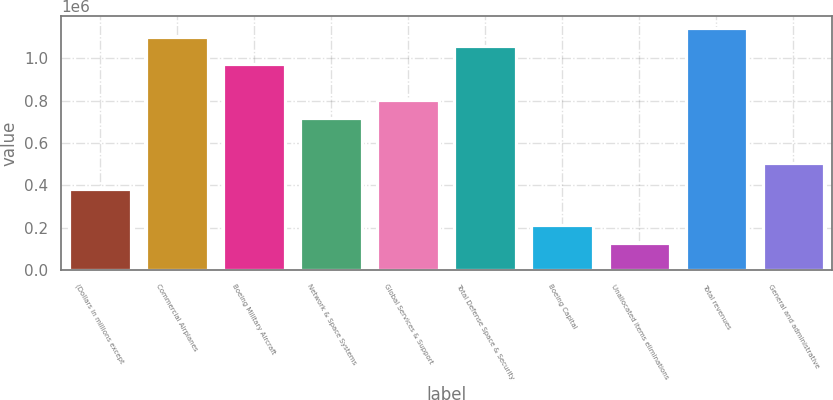Convert chart to OTSL. <chart><loc_0><loc_0><loc_500><loc_500><bar_chart><fcel>(Dollars in millions except<fcel>Commercial Airplanes<fcel>Boeing Military Aircraft<fcel>Network & Space Systems<fcel>Global Services & Support<fcel>Total Defense Space & Security<fcel>Boeing Capital<fcel>Unallocated items eliminations<fcel>Total revenues<fcel>General and administrative<nl><fcel>380395<fcel>1.09892e+06<fcel>972117<fcel>718522<fcel>803054<fcel>1.05665e+06<fcel>211332<fcel>126800<fcel>1.14118e+06<fcel>507193<nl></chart> 